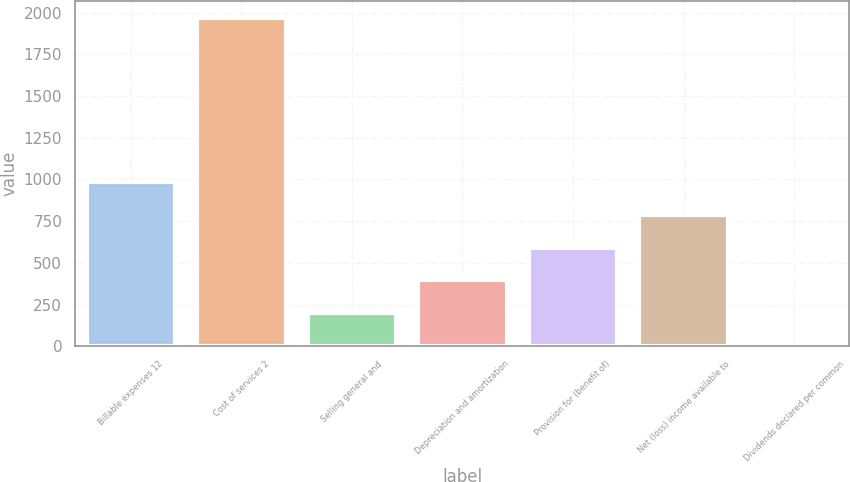<chart> <loc_0><loc_0><loc_500><loc_500><bar_chart><fcel>Billable expenses 12<fcel>Cost of services 2<fcel>Selling general and<fcel>Depreciation and amortization<fcel>Provision for (benefit of)<fcel>Net (loss) income available to<fcel>Dividends declared per common<nl><fcel>985.21<fcel>1970.2<fcel>197.21<fcel>394.21<fcel>591.21<fcel>788.21<fcel>0.21<nl></chart> 